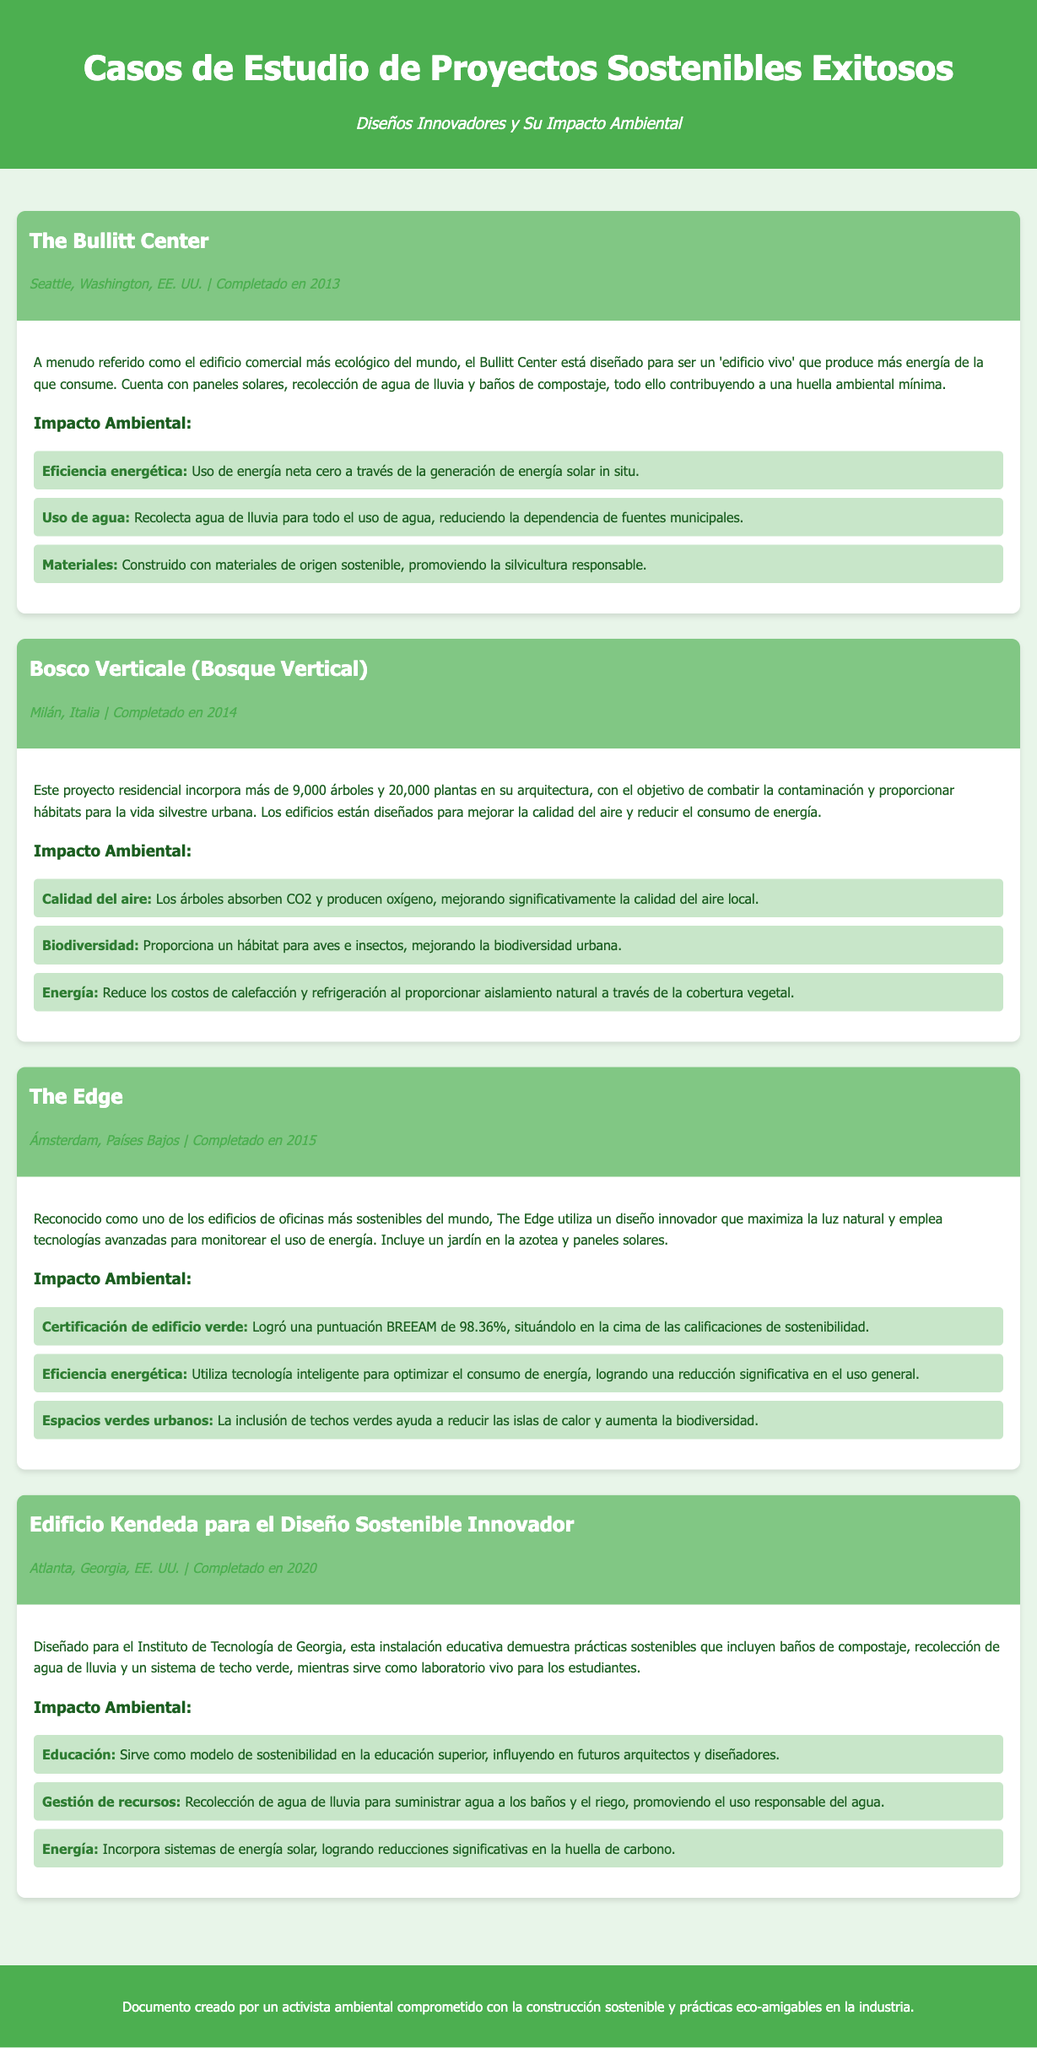¿Cuál es el nombre del proyecto ubicado en Atlanta? El proyecto se llama "Edificio Kendeda para el Diseño Sostenible Innovador."
Answer: Edificio Kendeda para el Diseño Sostenible Innovador ¿Qué año fue completado el Bosco Verticale? El Bosco Verticale fue completado en 2014.
Answer: 2014 ¿Cuántos árboles fueron incorporados en el Bosco Verticale? El Bosco Verticale incorpora más de 9,000 árboles.
Answer: 9,000 ¿Qué certificación obtuvo The Edge? The Edge logró una puntuación BREEAM de 98.36%.
Answer: BREEAM 98.36% ¿Cuál es una de las características del Bullitt Center? El Bullitt Center tiene paneles solares.
Answer: Paneles solares ¿Cómo se utiliza el agua en el Edificio Kendeda? El edificio recolecta agua de lluvia para suministrar agua a los baños.
Answer: Recolección de agua de lluvia ¿Qué aspecto innovador tiene el diseño de The Edge? El diseño maximiza la luz natural.
Answer: Maximiza la luz natural ¿Cuál es el impacto ambiental destacado del Bullitt Center? El Bullitt Center usa energía neta cero.
Answer: Energía neta cero 